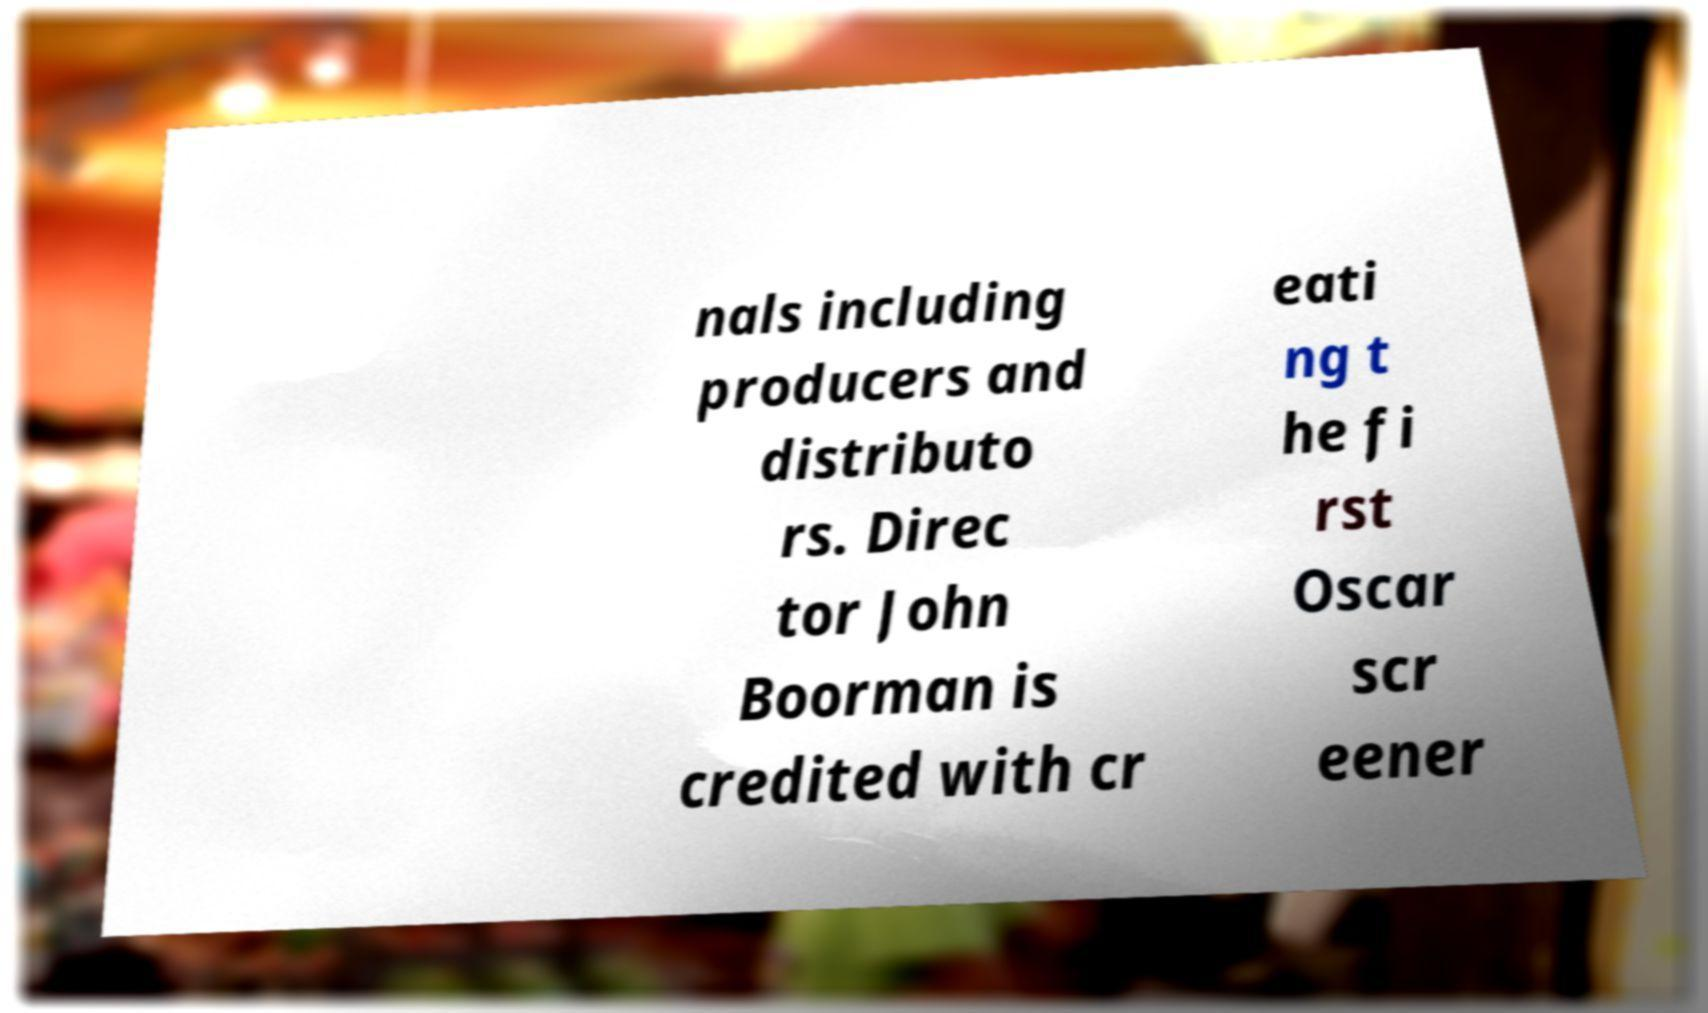Can you accurately transcribe the text from the provided image for me? nals including producers and distributo rs. Direc tor John Boorman is credited with cr eati ng t he fi rst Oscar scr eener 